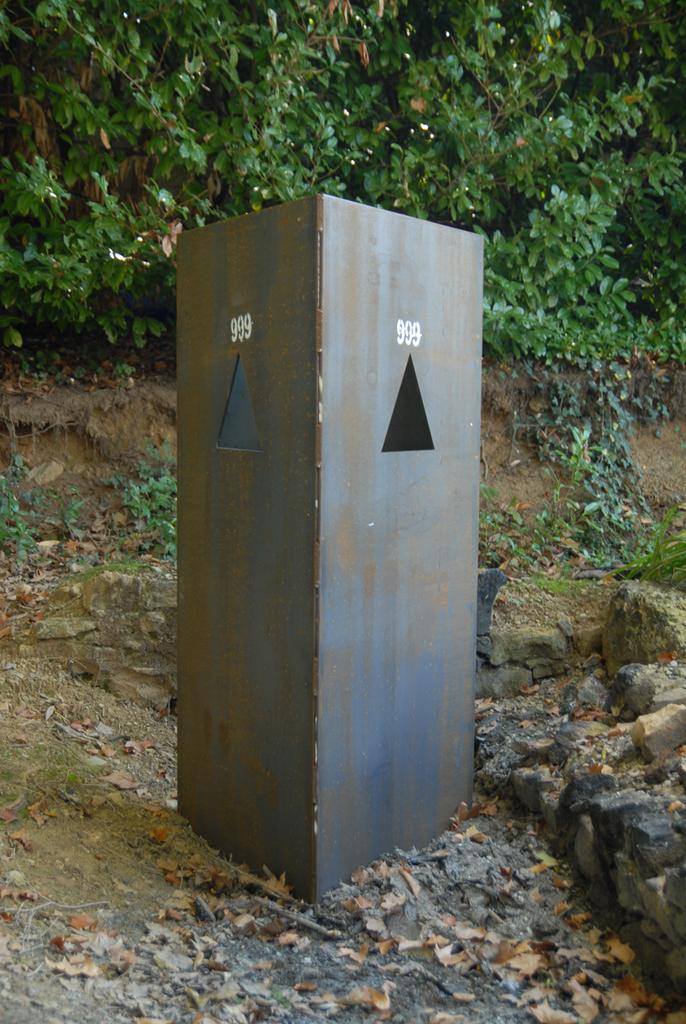What object is present on the ground in the image? There is an iron box in the image, and it is kept on the ground. What is covering the ground in the image? The ground is covered with dry leaves. What type of vegetation can be seen in the image? There are plants visible in the image. How many books are being sorted on the day depicted in the image? There are no books or any indication of sorting or a specific day in the image; it features an iron box on the ground with dry leaves and plants in the background. 